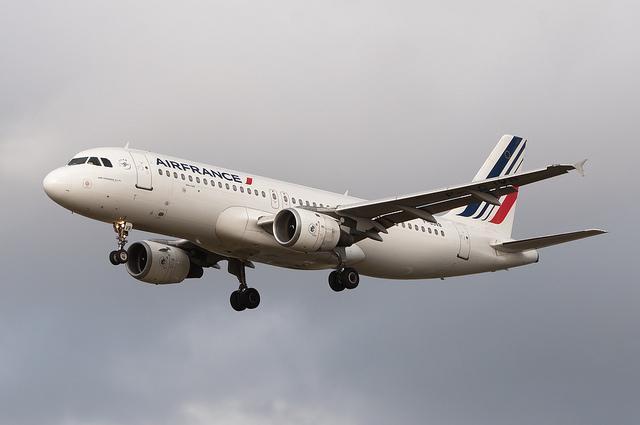How many donuts are there?
Give a very brief answer. 0. 